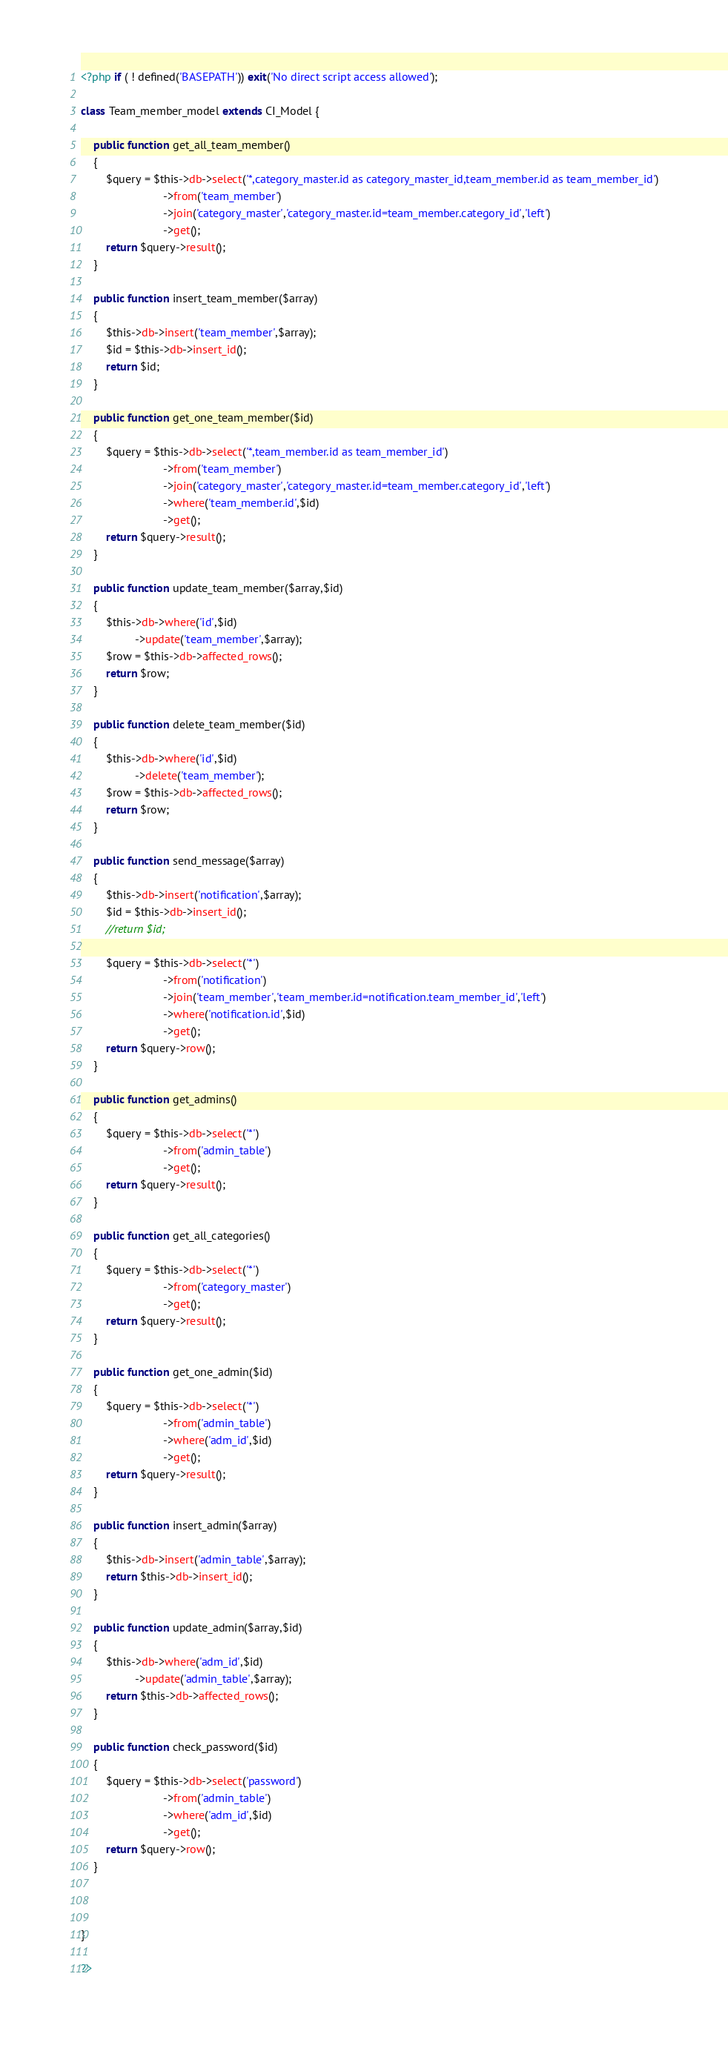Convert code to text. <code><loc_0><loc_0><loc_500><loc_500><_PHP_><?php if ( ! defined('BASEPATH')) exit('No direct script access allowed');

class Team_member_model extends CI_Model {
    
    public function get_all_team_member()
    {
        $query = $this->db->select('*,category_master.id as category_master_id,team_member.id as team_member_id')
                          ->from('team_member')
                          ->join('category_master','category_master.id=team_member.category_id','left')
                          ->get();
        return $query->result();
    }
    
    public function insert_team_member($array)
    {
        $this->db->insert('team_member',$array);
        $id = $this->db->insert_id();
        return $id;
    }
    
    public function get_one_team_member($id)
    {
        $query = $this->db->select('*,team_member.id as team_member_id')
                          ->from('team_member')
                          ->join('category_master','category_master.id=team_member.category_id','left')
                          ->where('team_member.id',$id)
                          ->get();
        return $query->result();
    }
    
    public function update_team_member($array,$id)
    {
        $this->db->where('id',$id)
                 ->update('team_member',$array);
        $row = $this->db->affected_rows();
        return $row;
    }
    
    public function delete_team_member($id)
    {
        $this->db->where('id',$id)
                 ->delete('team_member');
        $row = $this->db->affected_rows();
        return $row;
    }
    
    public function send_message($array)
    {
        $this->db->insert('notification',$array);
        $id = $this->db->insert_id();
        //return $id;
        
        $query = $this->db->select('*')
                          ->from('notification')
                          ->join('team_member','team_member.id=notification.team_member_id','left')
                          ->where('notification.id',$id)
                          ->get();
        return $query->row();
    }
    
    public function get_admins()
    {
        $query = $this->db->select('*')
                          ->from('admin_table')
                          ->get();
        return $query->result();
    }
    
    public function get_all_categories()
    {
        $query = $this->db->select('*')
                          ->from('category_master')
                          ->get();
        return $query->result();
    }
    
    public function get_one_admin($id)
    {
        $query = $this->db->select('*')
                          ->from('admin_table')
                          ->where('adm_id',$id)
                          ->get();
        return $query->result();
    }
    
    public function insert_admin($array)
    {
        $this->db->insert('admin_table',$array);
        return $this->db->insert_id();
    }
    
    public function update_admin($array,$id)
    {
        $this->db->where('adm_id',$id)
                 ->update('admin_table',$array);
        return $this->db->affected_rows();
    }
    
    public function check_password($id)
    {
        $query = $this->db->select('password')
                          ->from('admin_table')
                          ->where('adm_id',$id)
                          ->get();
        return $query->row();
    }
    
    
    
}

?></code> 